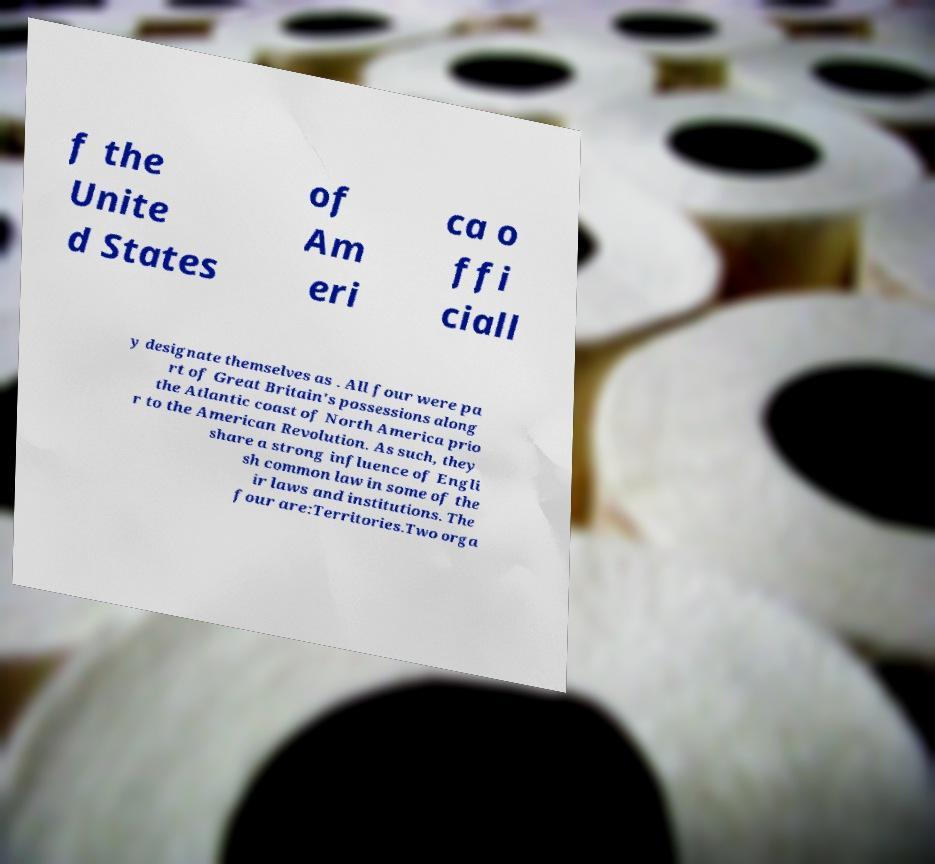Could you extract and type out the text from this image? f the Unite d States of Am eri ca o ffi ciall y designate themselves as . All four were pa rt of Great Britain's possessions along the Atlantic coast of North America prio r to the American Revolution. As such, they share a strong influence of Engli sh common law in some of the ir laws and institutions. The four are:Territories.Two orga 